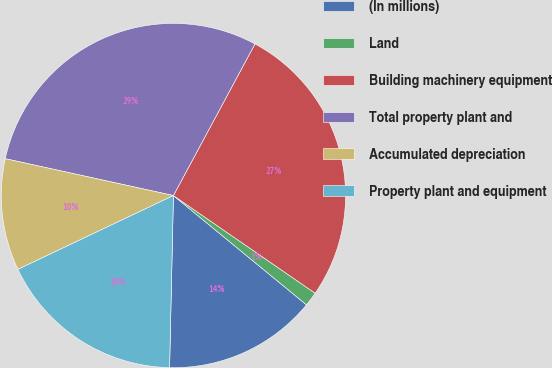Convert chart to OTSL. <chart><loc_0><loc_0><loc_500><loc_500><pie_chart><fcel>(In millions)<fcel>Land<fcel>Building machinery equipment<fcel>Total property plant and<fcel>Accumulated depreciation<fcel>Property plant and equipment<nl><fcel>14.41%<fcel>1.34%<fcel>26.75%<fcel>29.42%<fcel>10.49%<fcel>17.59%<nl></chart> 